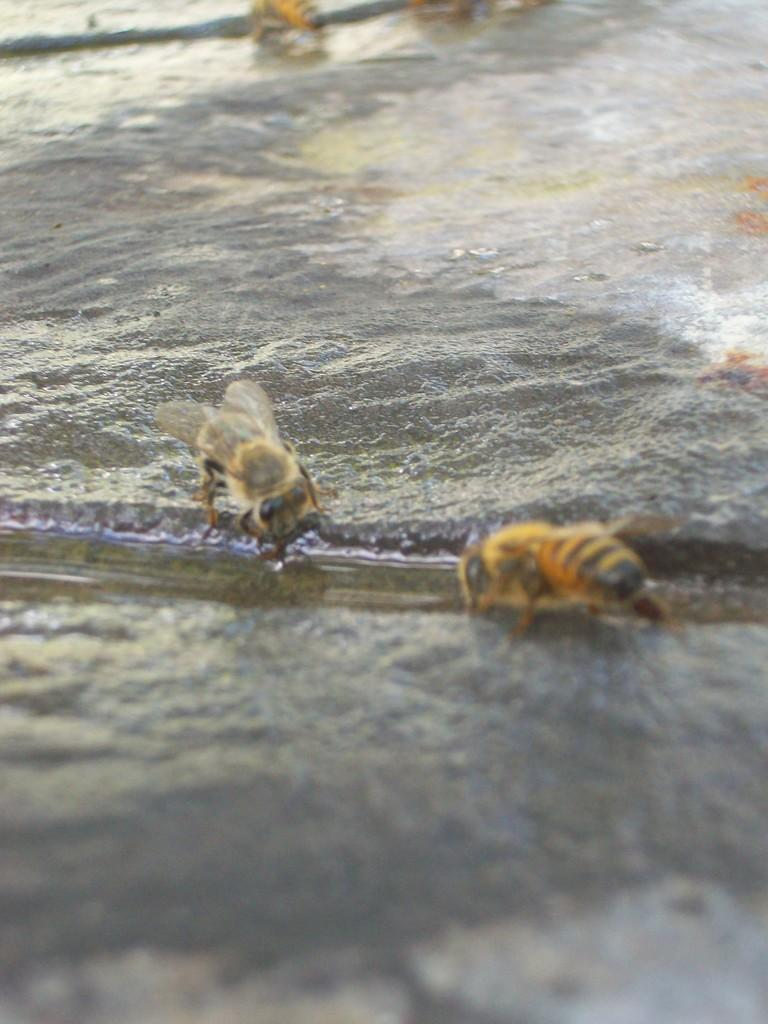What type of insects can be seen in the image? There are two flies in the image. Where are the flies located in the image? The flies are on the floor. What type of stamp can be seen on the library book in the image? There is no library book or stamp present in the image; it only features two flies on the floor. 